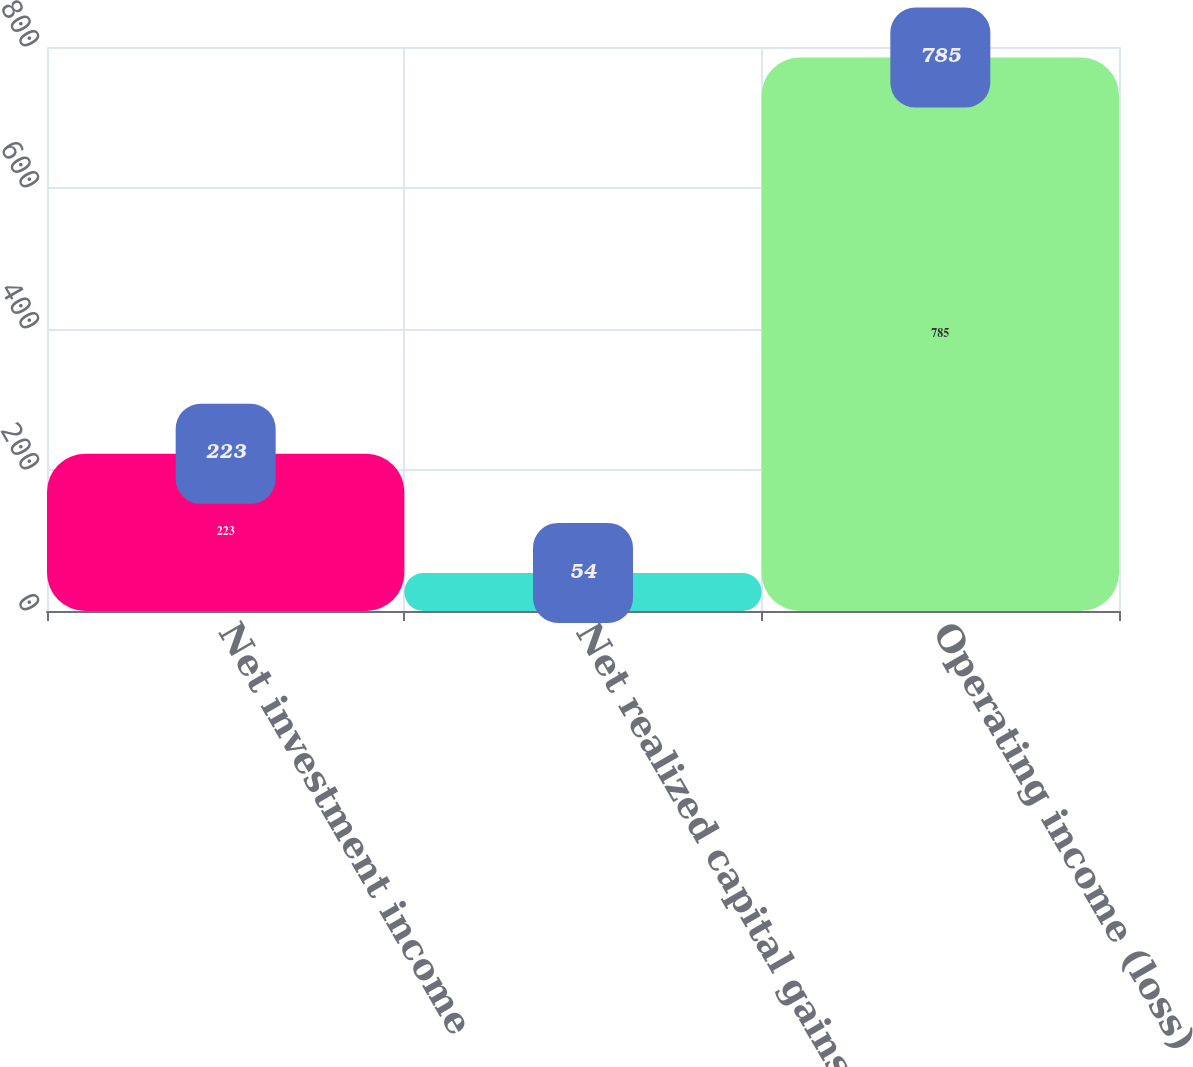Convert chart. <chart><loc_0><loc_0><loc_500><loc_500><bar_chart><fcel>Net investment income<fcel>Net realized capital gains<fcel>Operating income (loss)<nl><fcel>223<fcel>54<fcel>785<nl></chart> 